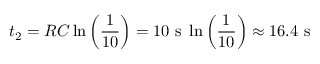<formula> <loc_0><loc_0><loc_500><loc_500>t _ { 2 } = R C \ln { \left ( \frac { 1 } { 1 0 } \right ) } = 1 0 s \ln { \left ( \frac { 1 } { 1 0 } \right ) } \approx 1 6 . 4 s</formula> 